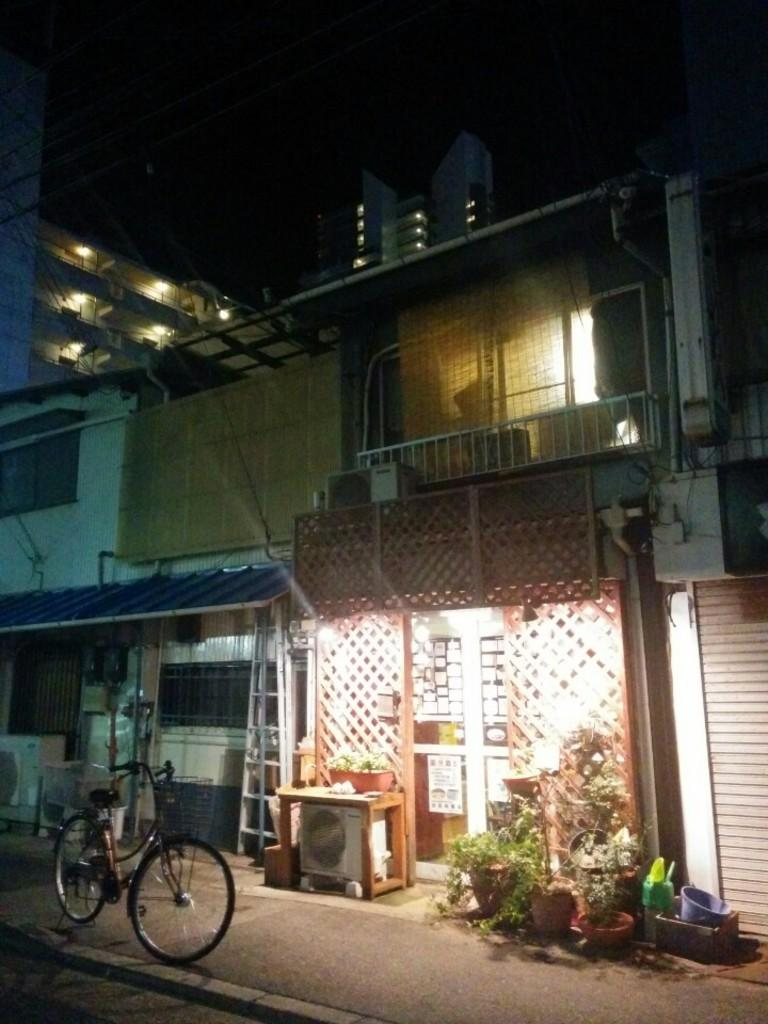What is the main object on the road in the image? There is a bicycle on the road in the image. What type of structure can be seen in the image? There is a building in the image. What type of vegetation is present in the image? There are plants in the image. What can be seen illuminating the scene in the image? There are lights visible in the image. What type of harmony can be heard in the image? There is no audible sound in the image, so it is not possible to determine if any harmony can be heard. 